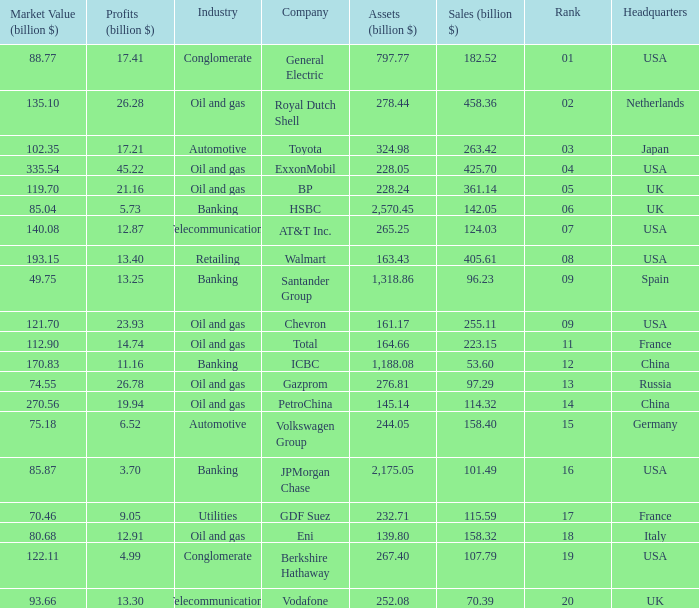What is the smallest market value (in billion dollars) for a company with assets greater than $276.81 billion, belonging to toyota, and with profits exceeding $17.21 billion? None. 